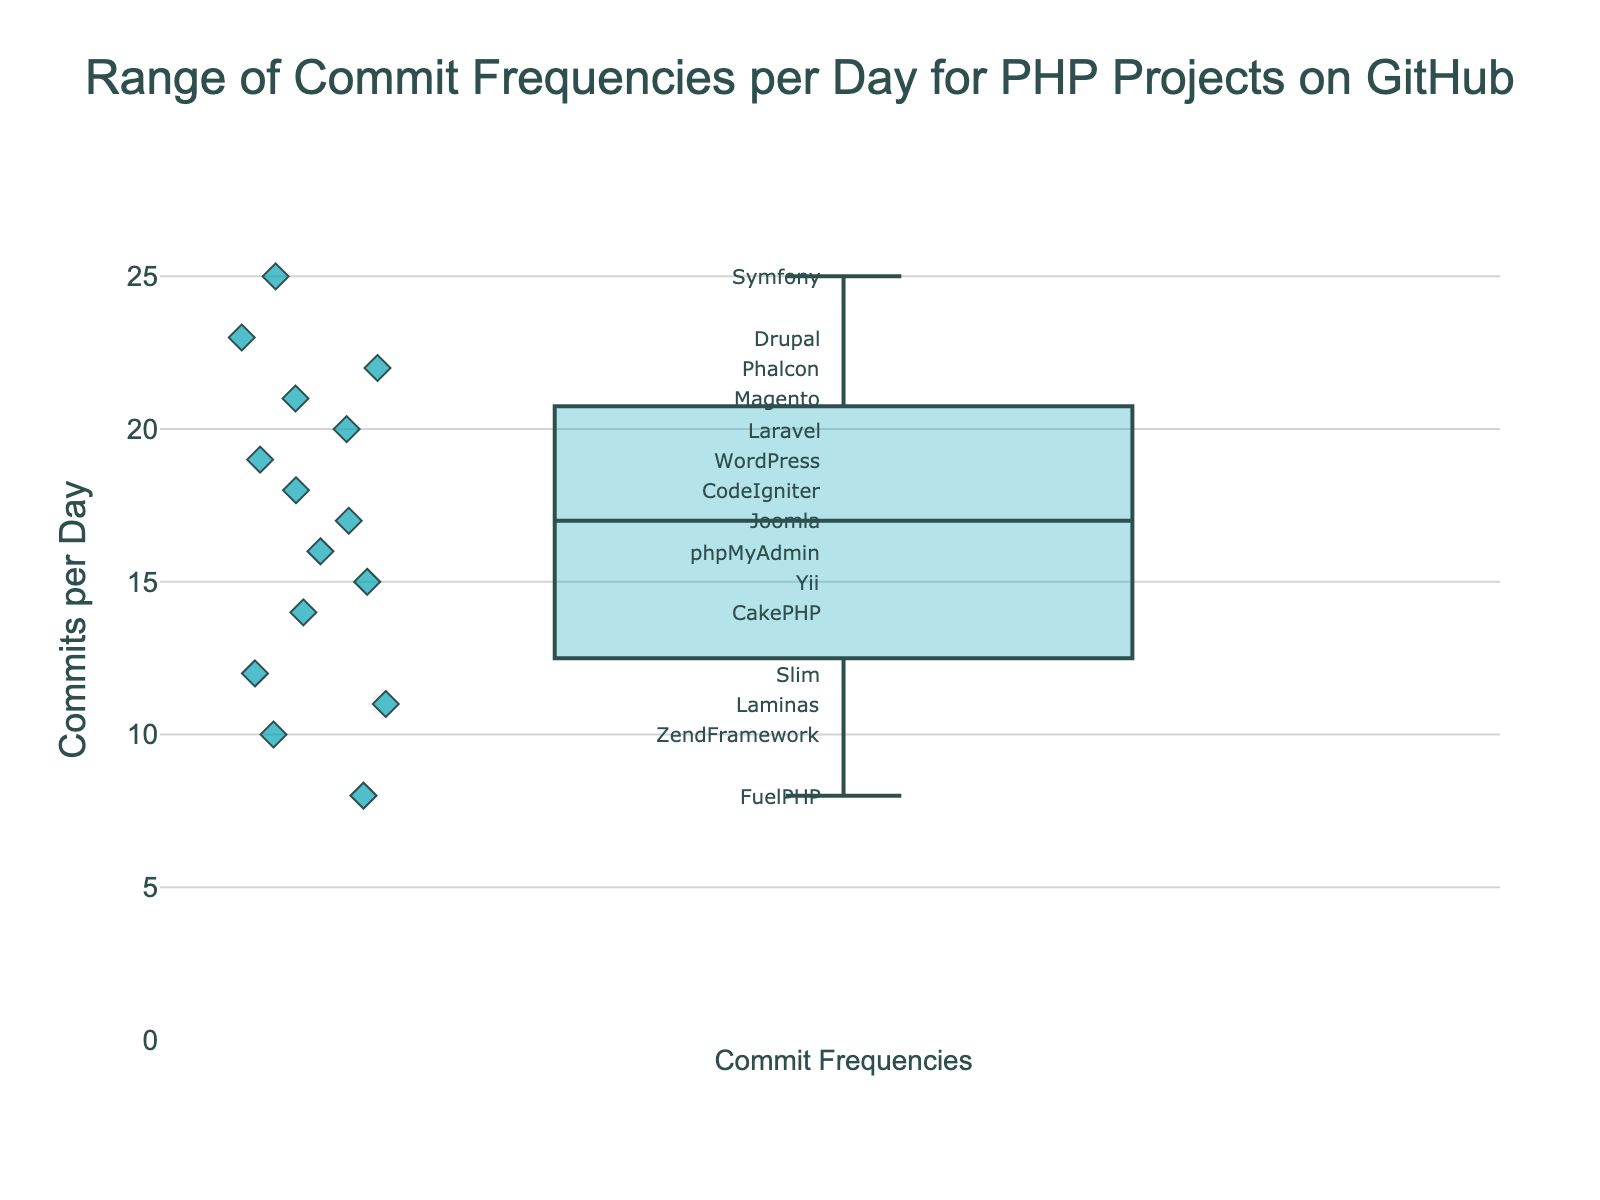What is the title of the box plot? The title of the box plot is located at the top center of the plot and typically contains a summarization of the plot's focus. In this case, it reads "Range of Commit Frequencies per Day for PHP Projects on GitHub".
Answer: Range of Commit Frequencies per Day for PHP Projects on GitHub What is the range of commit frequencies per day shown in the plot? The range of commit frequencies per day can be observed from the minimum to maximum y-axis values that the data points reach. It goes from 8 to 25 commits per day.
Answer: 8 to 25 commits per day Can you find the median value of commit frequencies per day? The median value is represented by the line inside the box of the box plot. By looking approximately in the middle, this line indicates around 17 commits per day.
Answer: 17 commits per day Which project has the highest commit frequency per day? The highest commit frequency can be identified by looking at the data point that reaches the maximum value on the y-axis. In this plot, that data point is annotated with the text "Symfony" at 25 commits per day.
Answer: Symfony Which projects have commit frequencies per day less than 10? Data points below 10 commits per day on the y-axis with their respective annotations represent the projects. In this case, there is only one, "FuelPHP", with 8 commits per day.
Answer: FuelPHP Between Laravel and Drupal, which project has a higher daily commit frequency? By comparing the data points annotated with "Laravel" and "Drupal", Laravel is placed at 20, while Drupal is at 23 commits per day. Therefore, Drupal has a higher commit frequency.
Answer: Drupal What is the interquartile range (IQR) of commit frequencies per day? The IQR is the range between the first quartile (Q1) and the third quartile (Q3) of the box plot. Visually estimating, Q1 is around 12 and Q3 is around 22. The difference between them (Q3 - Q1) gives us the IQR of approximately 10 commits per day.
Answer: 10 commits per day Which projects have more than 15 but less than 20 commits per day? Look for data points in the y-axis range between 15 and 20. The projects annotated within this range are "Yii" (15), "phpMyAdmin" (16), "Joomla" (17), and "WordPress" (19).
Answer: Yii, phpMyAdmin, Joomla, WordPress What is the upper whisker value in the box plot? The upper whisker typically extends from the third quartile (Q3) to the maximum value within 1.5 IQR from Q3. Since the highest commit frequency (max data point) is 25 and it’s part of the data points, the upper whisker value is 25.
Answer: 25 Which project sits closest to the median commit frequency value? The median is roughly at 17 commits per day. The project annotated with a commit frequency closest to this value is "Joomla" which is just at 17.
Answer: Joomla 